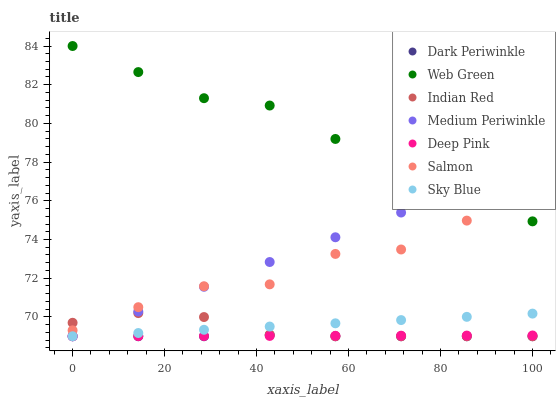Does Dark Periwinkle have the minimum area under the curve?
Answer yes or no. Yes. Does Web Green have the maximum area under the curve?
Answer yes or no. Yes. Does Medium Periwinkle have the minimum area under the curve?
Answer yes or no. No. Does Medium Periwinkle have the maximum area under the curve?
Answer yes or no. No. Is Deep Pink the smoothest?
Answer yes or no. Yes. Is Salmon the roughest?
Answer yes or no. Yes. Is Medium Periwinkle the smoothest?
Answer yes or no. No. Is Medium Periwinkle the roughest?
Answer yes or no. No. Does Deep Pink have the lowest value?
Answer yes or no. Yes. Does Salmon have the lowest value?
Answer yes or no. No. Does Web Green have the highest value?
Answer yes or no. Yes. Does Medium Periwinkle have the highest value?
Answer yes or no. No. Is Sky Blue less than Salmon?
Answer yes or no. Yes. Is Salmon greater than Deep Pink?
Answer yes or no. Yes. Does Indian Red intersect Dark Periwinkle?
Answer yes or no. Yes. Is Indian Red less than Dark Periwinkle?
Answer yes or no. No. Is Indian Red greater than Dark Periwinkle?
Answer yes or no. No. Does Sky Blue intersect Salmon?
Answer yes or no. No. 